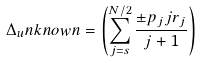<formula> <loc_0><loc_0><loc_500><loc_500>\Delta _ { u } n k n o w n = \left ( \sum _ { j = s } ^ { N / 2 } \frac { \pm p _ { j } j { r } _ { j } } { j + 1 } \right )</formula> 